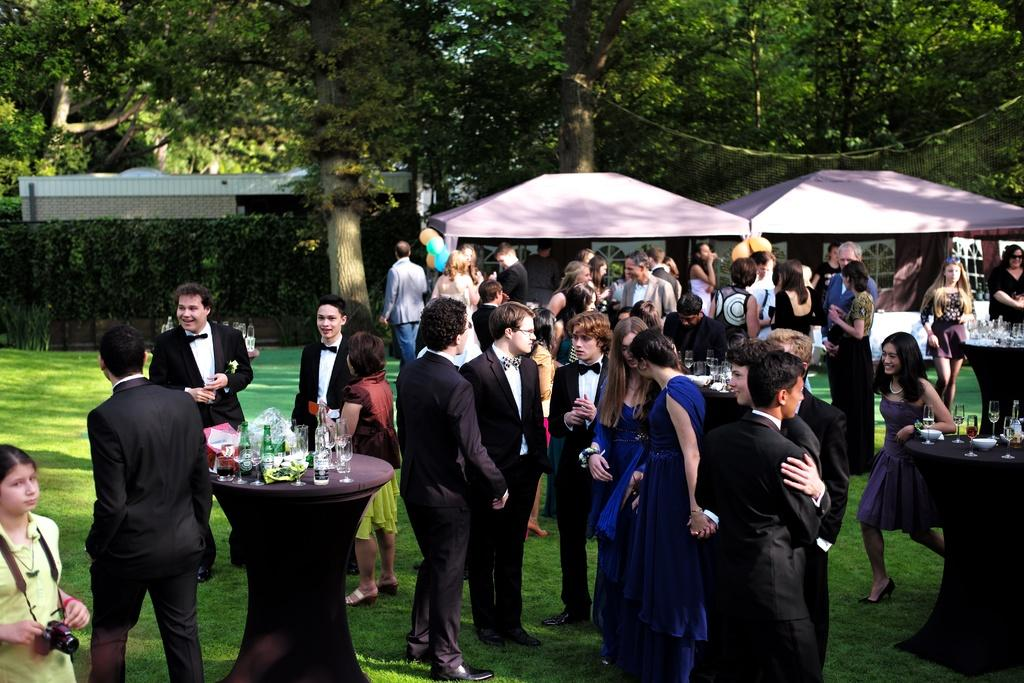What can be seen in the image involving people? There are persons standing in the image. What type of shelter is present in the image? There is a tent in the image. What piece of furniture is in the image? There is a table in the image. What items are on the table? There is a glass and a bottle on the table. What can be seen in the background of the image? There are trees in the background of the image. What type of fuel is being used by the owl in the image? There is no owl present in the image, so the question about fuel cannot be answered. 